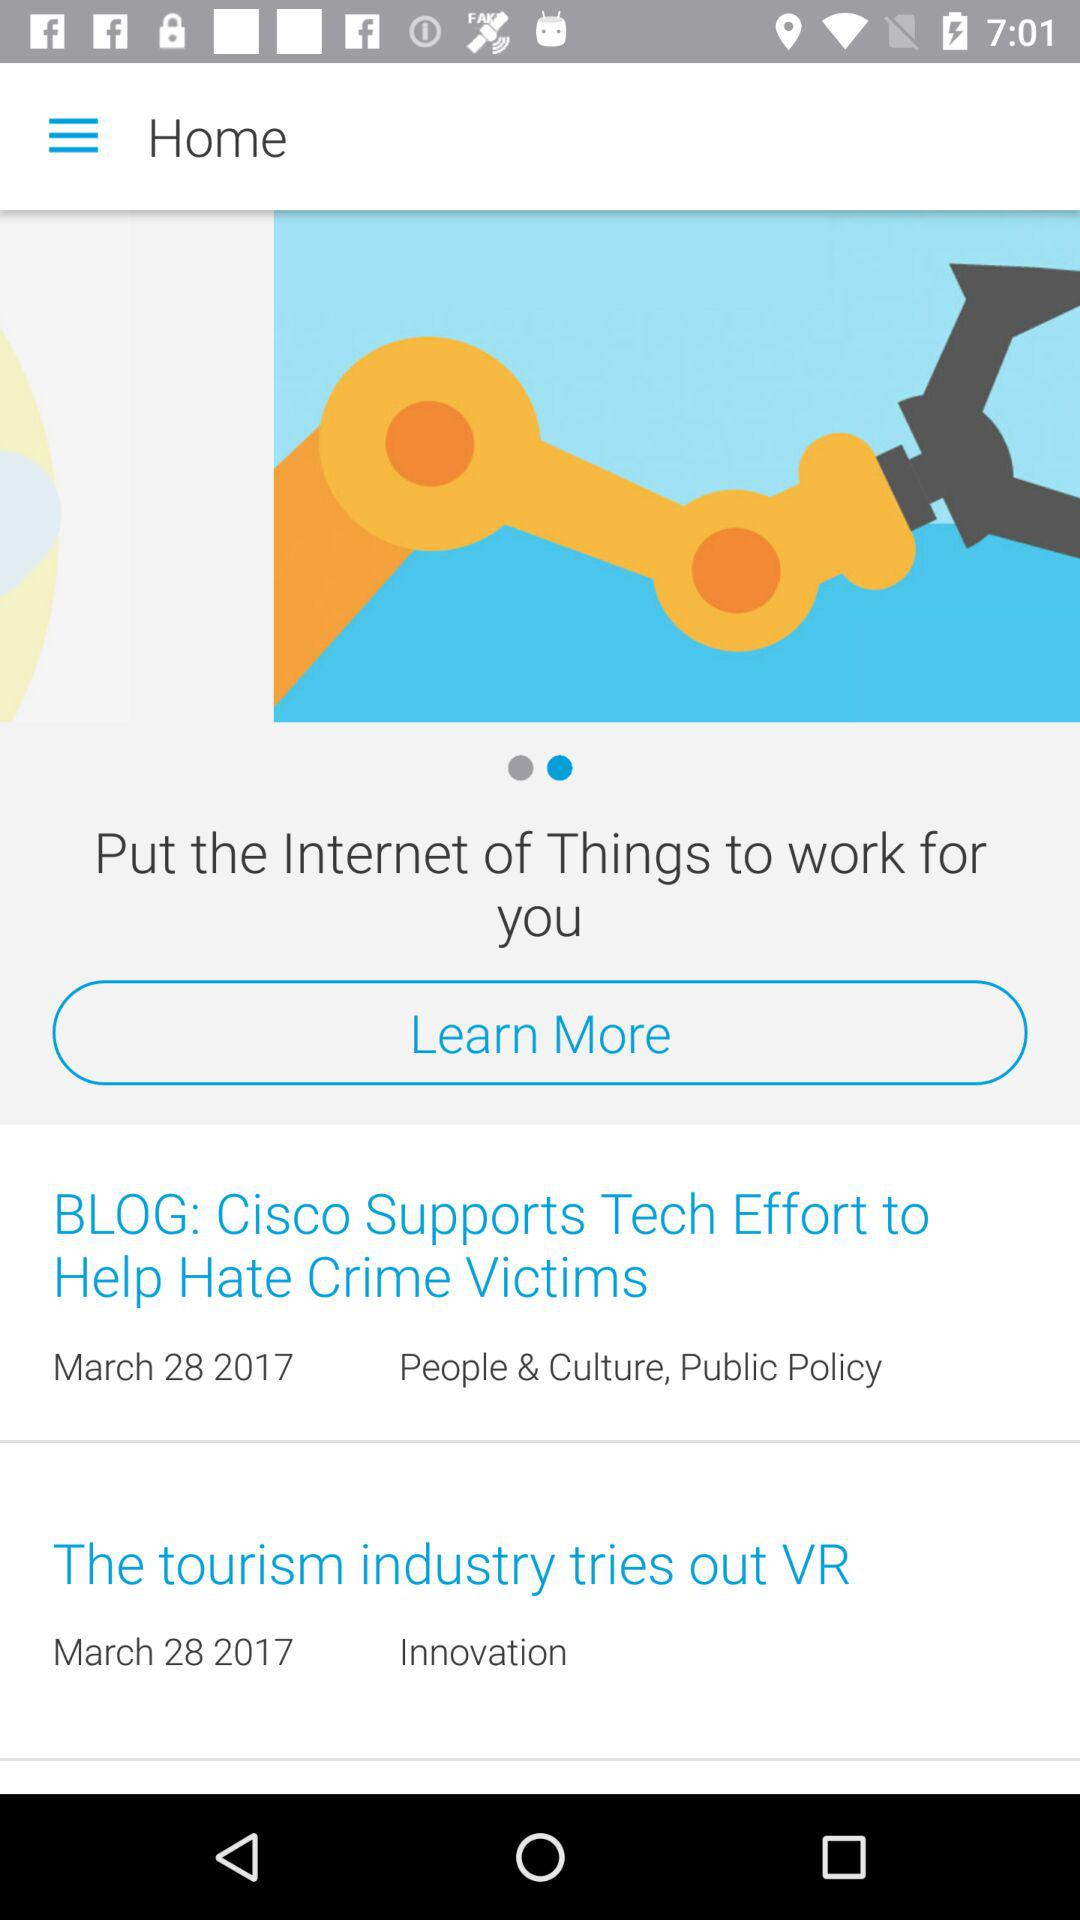Which headline belongs to the categories "People & Culture" and "Public Policy"? The headline is "BLOG: Cisco Supports Tech Effort to Help Hate Crime Victims". 